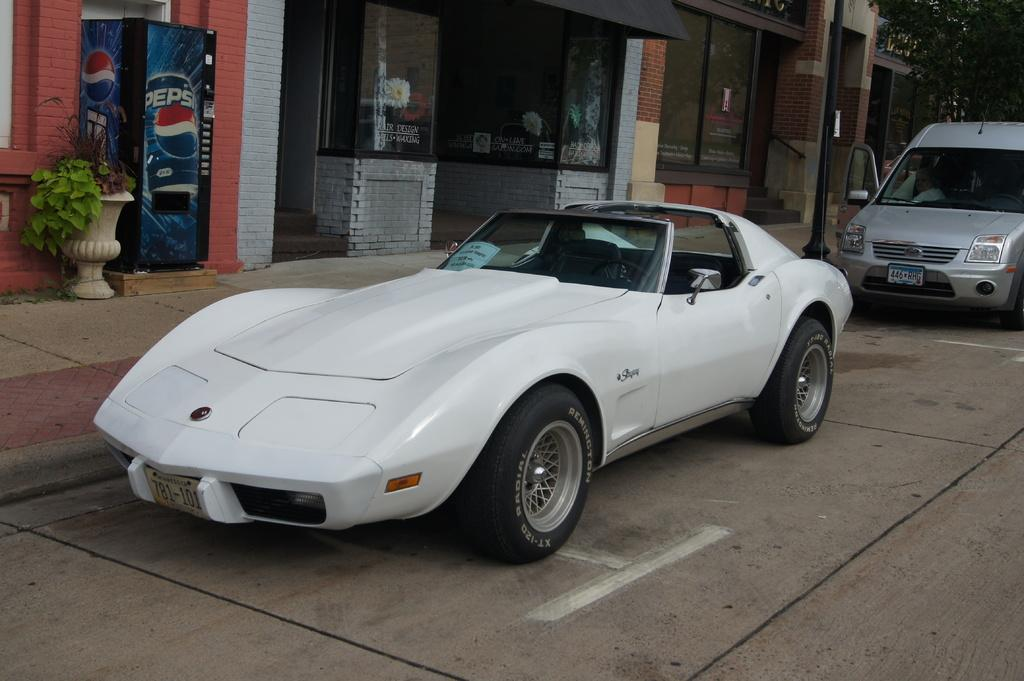What can be seen on the road in the image? There are vehicles on the road in the image. What type of structures are visible in the image? There are buildings in the image. What appliance can be seen in the image? There is a refrigerator in the image. What type of plant container is present in the image? There is a flower pot in the image. What type of vegetation is visible in the image? There are trees in the image. What vertical object can be seen in the image? There is a pole in the image. Can you see a robin perched on the refrigerator in the image? There is no robin visible in the image. 